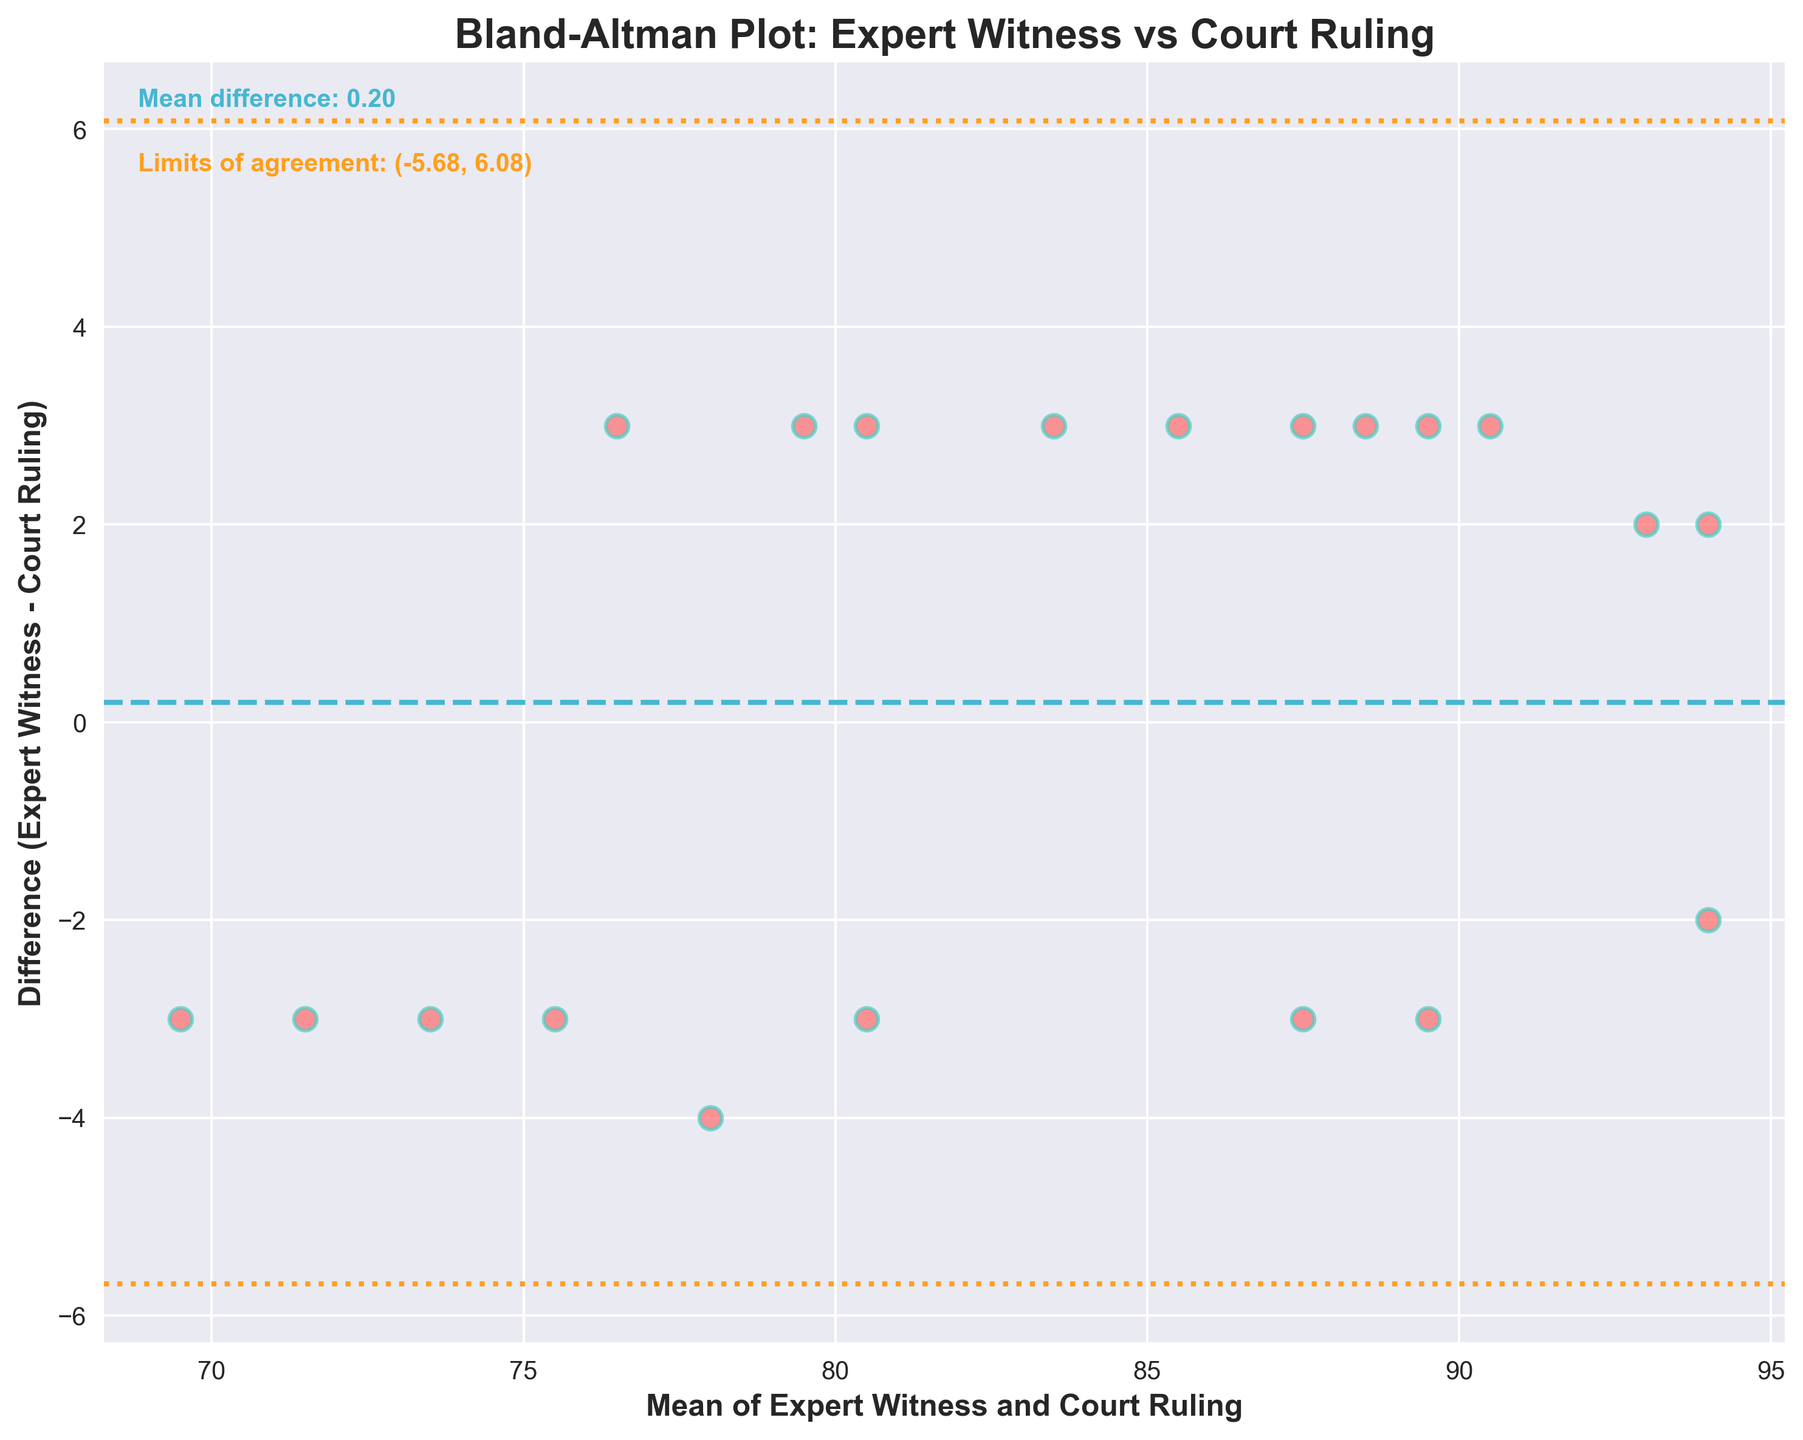What is the title of the figure? The title can be found at the top of the figure. It is written in large, bold font.
Answer: Bland-Altman Plot: Expert Witness vs Court Ruling How many data points are there in the figure? The number of data points corresponds to the number of scattered points present in the plot. Each point represents one observation. By counting these points, we find there are 20 data points.
Answer: 20 What is the mean difference between Expert Witness and Court Ruling? The mean difference is explicitly stated in the text on the figure, typically around the top-left area in a font different from the axes labels.
Answer: 0.10 What are the limits of agreement? The limits of agreement are indicated on the plot by two horizontal dashed lines. The values for these limits are also labeled in the text near the top-left corner.
Answer: -2.73, 2.93 What color are the data points on the plot? The color of the scattered data points can be identified by observing the points themselves. They appear in a bright red shade, outlined with a different color.
Answer: Red How are the axes labeled? The labels of the axes can be found at the ends of each axis, usually in bold font. The x-axis is labeled "Mean of Expert Witness and Court Ruling," and the y-axis is labeled "Difference (Expert Witness - Court Ruling)."
Answer: Mean of Expert Witness and Court Ruling, Difference (Expert Witness - Court Ruling) What is plotted on the x-axis and y-axis? The x-axis displays the mean values of the Expert Witness and Court Ruling, while the y-axis displays the differences between Expert Witness and Court Ruling. This information is directly from the axis labels.
Answer: Mean values, Differences Which data point has the highest difference? By comparing the vertical positions of each point on the y-axis, the one with the highest positive value is the point (85, 82) with a difference of 3, and there are multiple such points. Observing the scattered points, the first one fulfills this criterion.
Answer: (85, 82) What’s the average of the mean values on the x-axis? To find this, sum up all the mean values (which are the averages of Expert Witness and Court Ruling for each data point) and then divide by the total number of data points, which is 20.
Answer: 83.05 Is there more agreement or disagreement between Expert Witness and Court Ruling? To determine this, observe if the data points mostly cluster around the mean difference line, or whether they fall within the limits of agreement. Most points lie within this range, indicating more agreement.
Answer: Agreement 